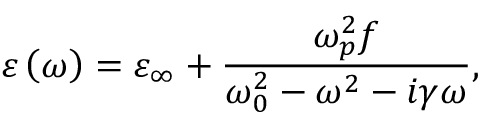Convert formula to latex. <formula><loc_0><loc_0><loc_500><loc_500>\varepsilon \left ( \omega \right ) = \varepsilon _ { \infty } + \frac { \omega _ { p } ^ { 2 } f } { \omega _ { 0 } ^ { 2 } - \omega ^ { 2 } - i \gamma \omega } ,</formula> 